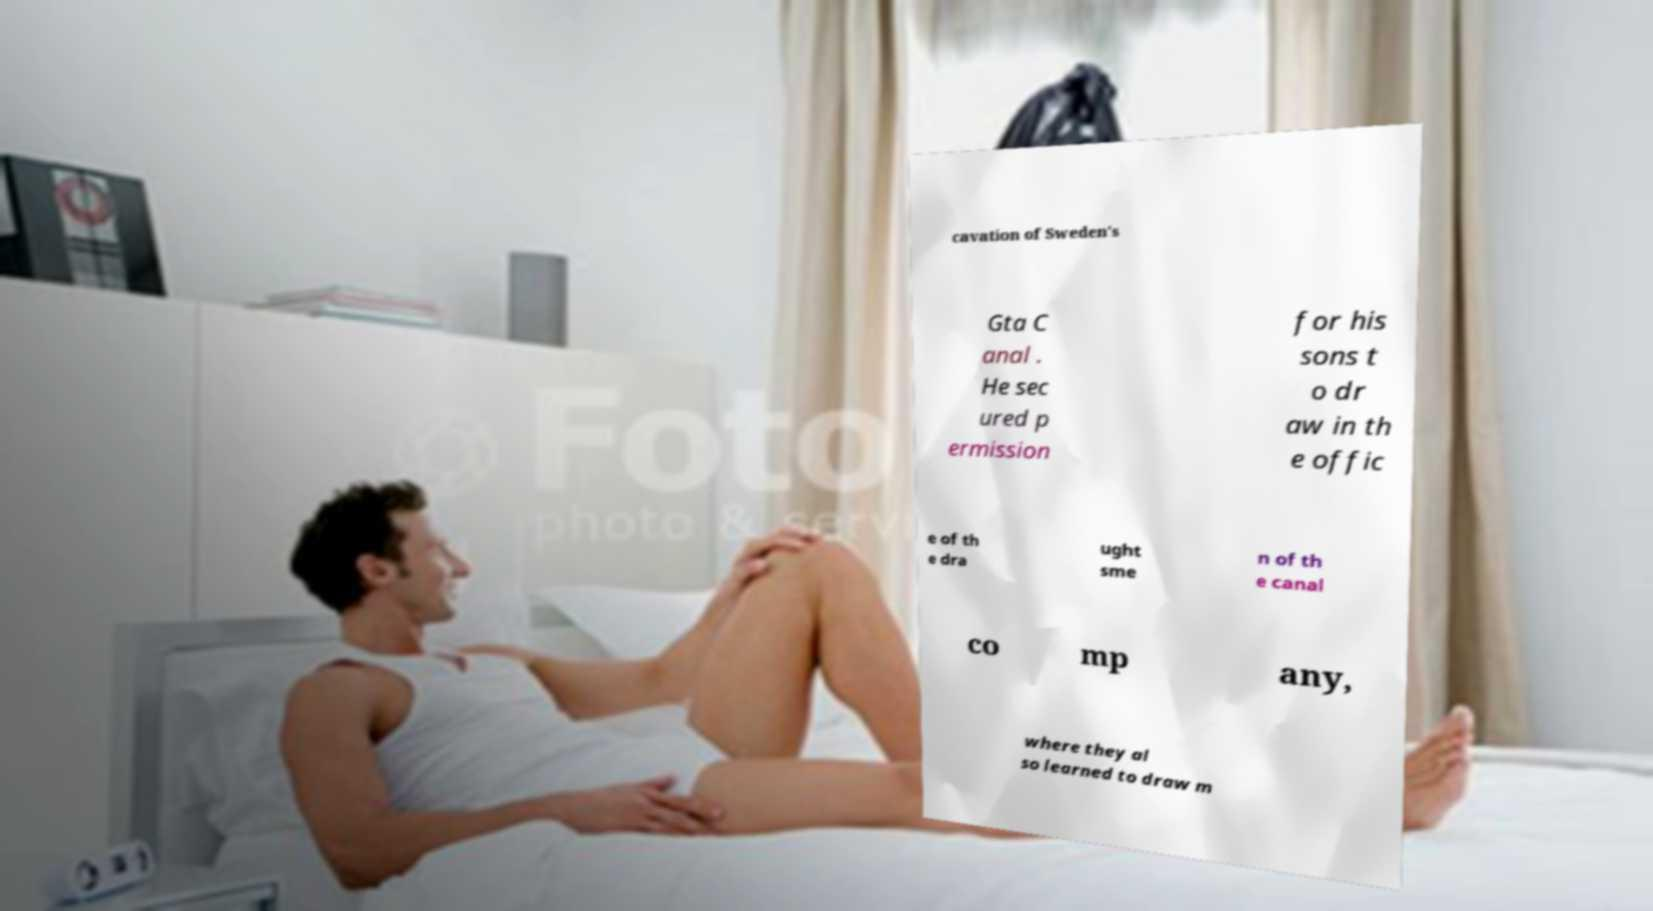Can you accurately transcribe the text from the provided image for me? cavation of Sweden's Gta C anal . He sec ured p ermission for his sons t o dr aw in th e offic e of th e dra ught sme n of th e canal co mp any, where they al so learned to draw m 